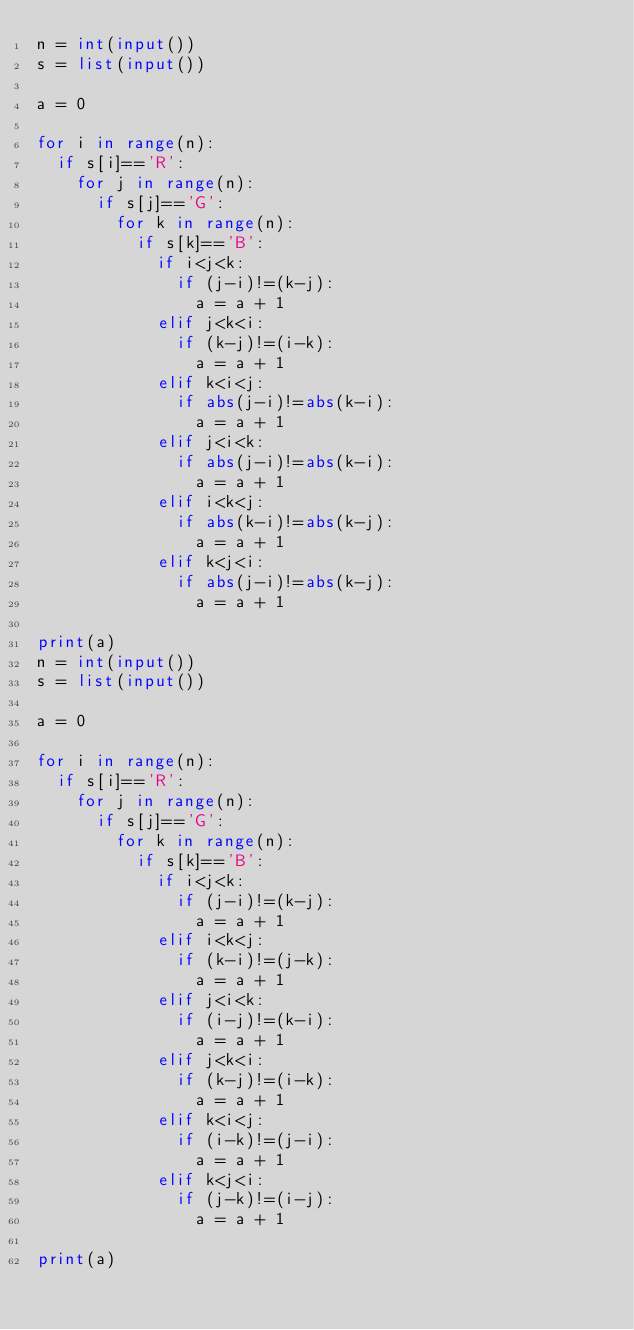Convert code to text. <code><loc_0><loc_0><loc_500><loc_500><_Python_>n = int(input())
s = list(input())
 
a = 0
 
for i in range(n):
  if s[i]=='R':
    for j in range(n):
      if s[j]=='G':
        for k in range(n):
          if s[k]=='B':
            if i<j<k:
              if (j-i)!=(k-j):
                a = a + 1
            elif j<k<i:
              if (k-j)!=(i-k):
                a = a + 1
            elif k<i<j:
              if abs(j-i)!=abs(k-i):
                a = a + 1
            elif j<i<k:
              if abs(j-i)!=abs(k-i):
                a = a + 1
            elif i<k<j:
              if abs(k-i)!=abs(k-j):
                a = a + 1
            elif k<j<i:
              if abs(j-i)!=abs(k-j):
                a = a + 1
          
print(a)
n = int(input())
s = list(input())

a = 0

for i in range(n):
  if s[i]=='R':
    for j in range(n):
      if s[j]=='G':
        for k in range(n):
          if s[k]=='B':
            if i<j<k:
              if (j-i)!=(k-j):
                a = a + 1
            elif i<k<j:
              if (k-i)!=(j-k):
                a = a + 1
            elif j<i<k:
              if (i-j)!=(k-i):
                a = a + 1
            elif j<k<i:
              if (k-j)!=(i-k):
                a = a + 1
            elif k<i<j:
              if (i-k)!=(j-i):
                a = a + 1
            elif k<j<i:
              if (j-k)!=(i-j):
                a = a + 1
          
print(a)</code> 